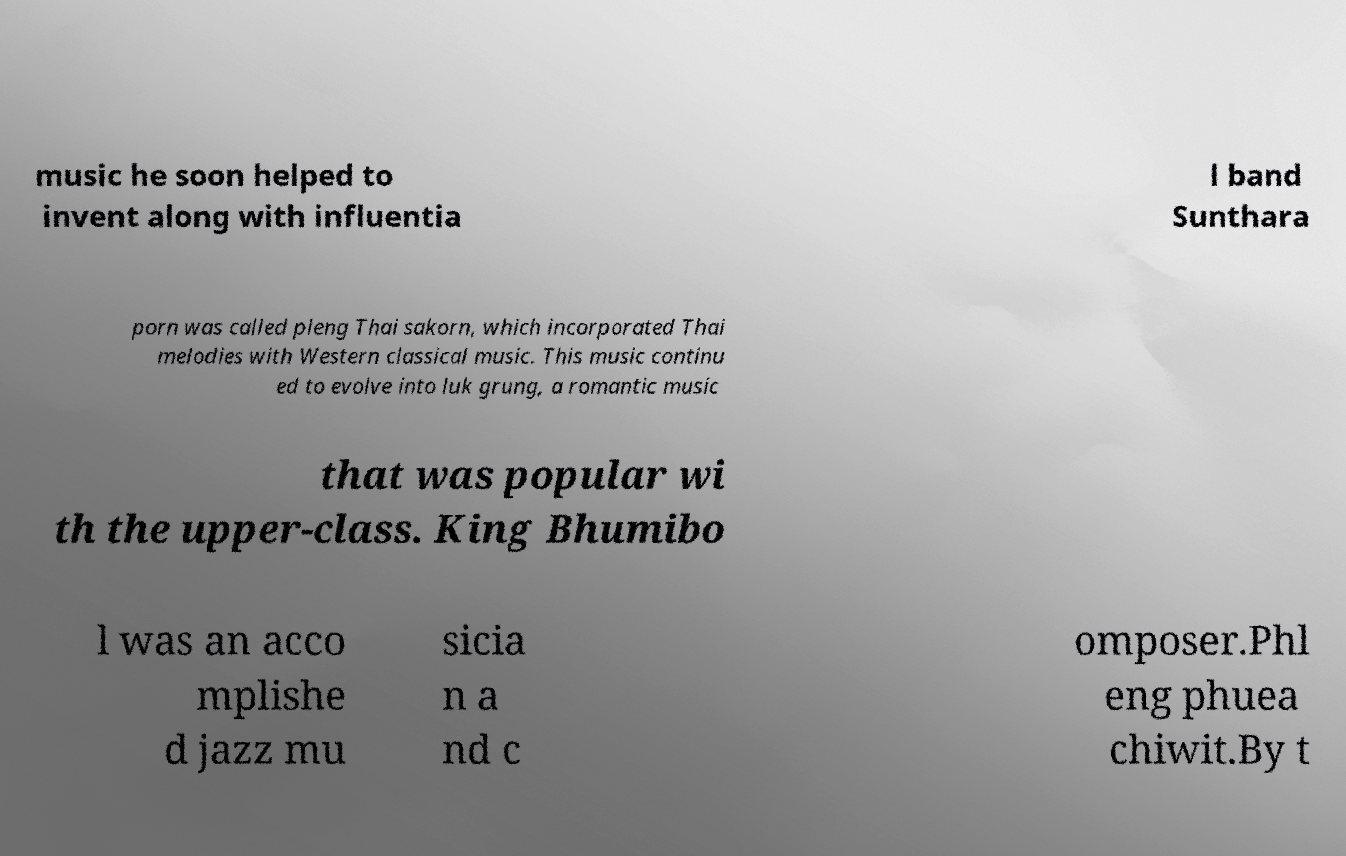Can you read and provide the text displayed in the image?This photo seems to have some interesting text. Can you extract and type it out for me? music he soon helped to invent along with influentia l band Sunthara porn was called pleng Thai sakorn, which incorporated Thai melodies with Western classical music. This music continu ed to evolve into luk grung, a romantic music that was popular wi th the upper-class. King Bhumibo l was an acco mplishe d jazz mu sicia n a nd c omposer.Phl eng phuea chiwit.By t 